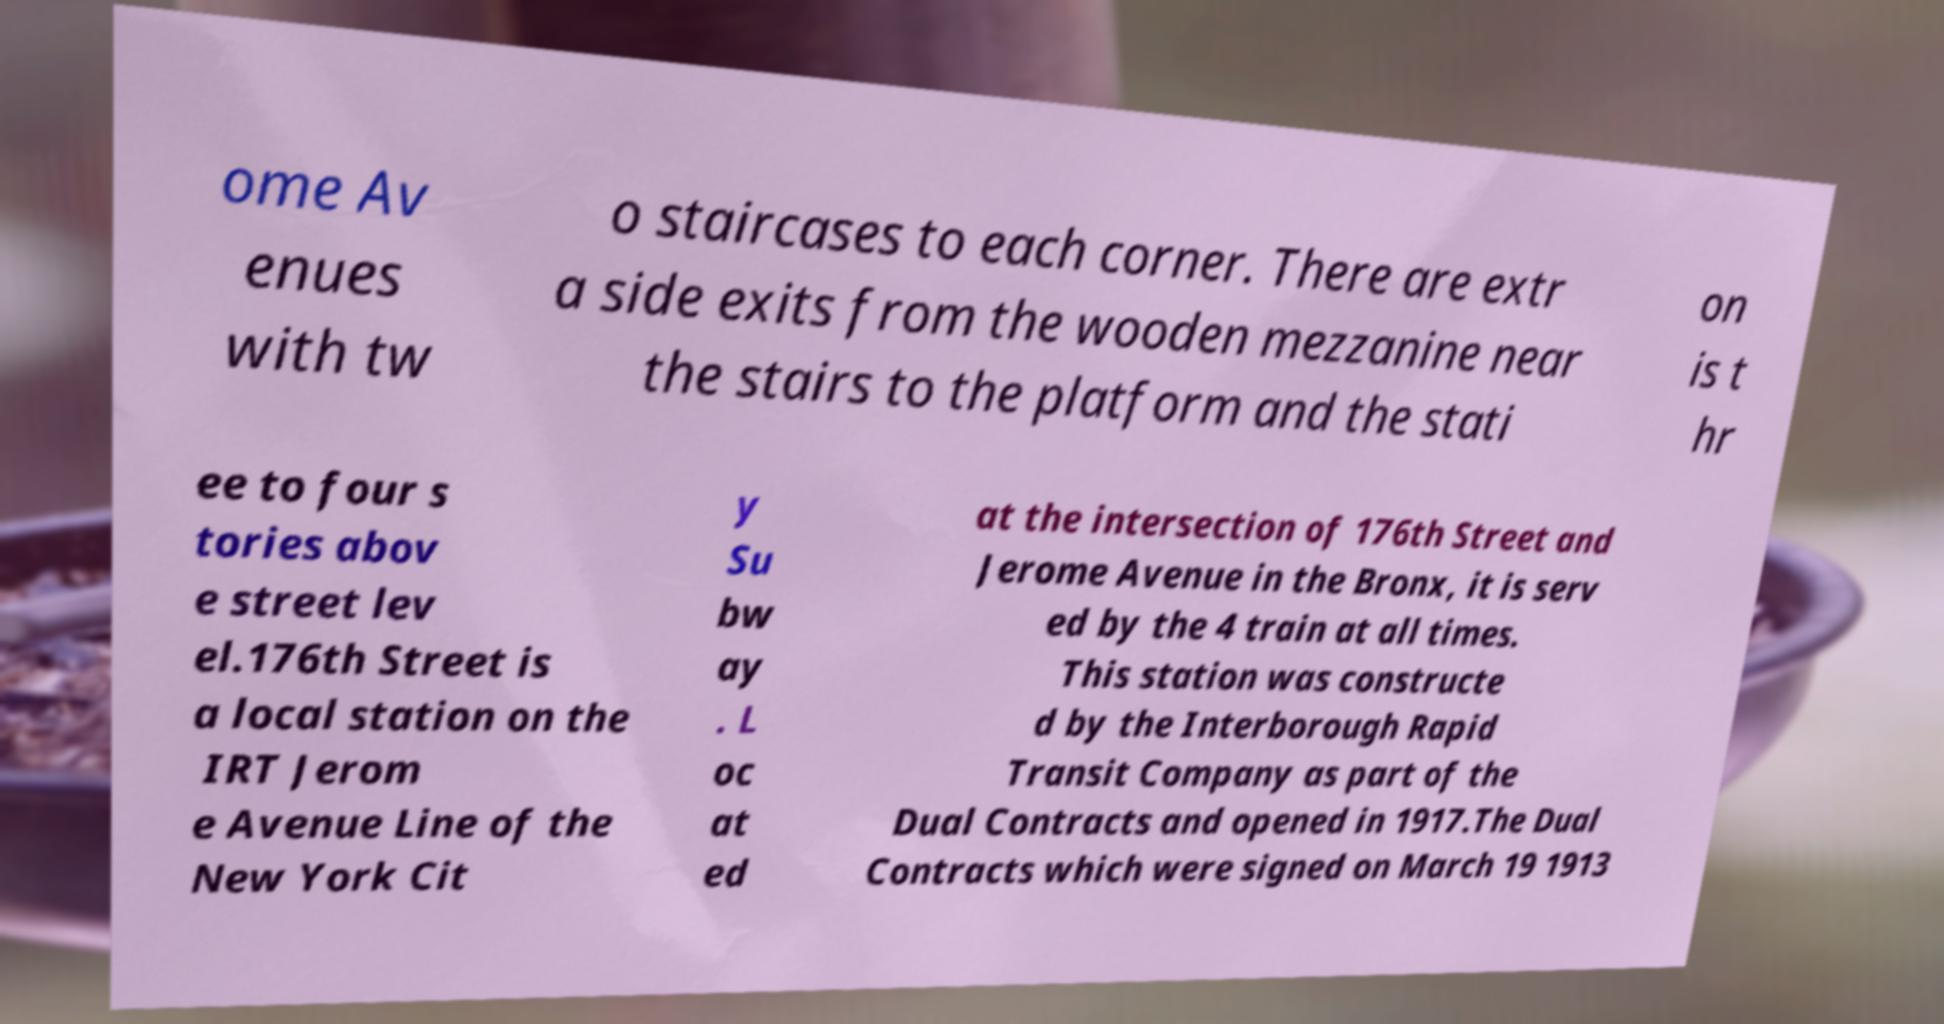There's text embedded in this image that I need extracted. Can you transcribe it verbatim? ome Av enues with tw o staircases to each corner. There are extr a side exits from the wooden mezzanine near the stairs to the platform and the stati on is t hr ee to four s tories abov e street lev el.176th Street is a local station on the IRT Jerom e Avenue Line of the New York Cit y Su bw ay . L oc at ed at the intersection of 176th Street and Jerome Avenue in the Bronx, it is serv ed by the 4 train at all times. This station was constructe d by the Interborough Rapid Transit Company as part of the Dual Contracts and opened in 1917.The Dual Contracts which were signed on March 19 1913 